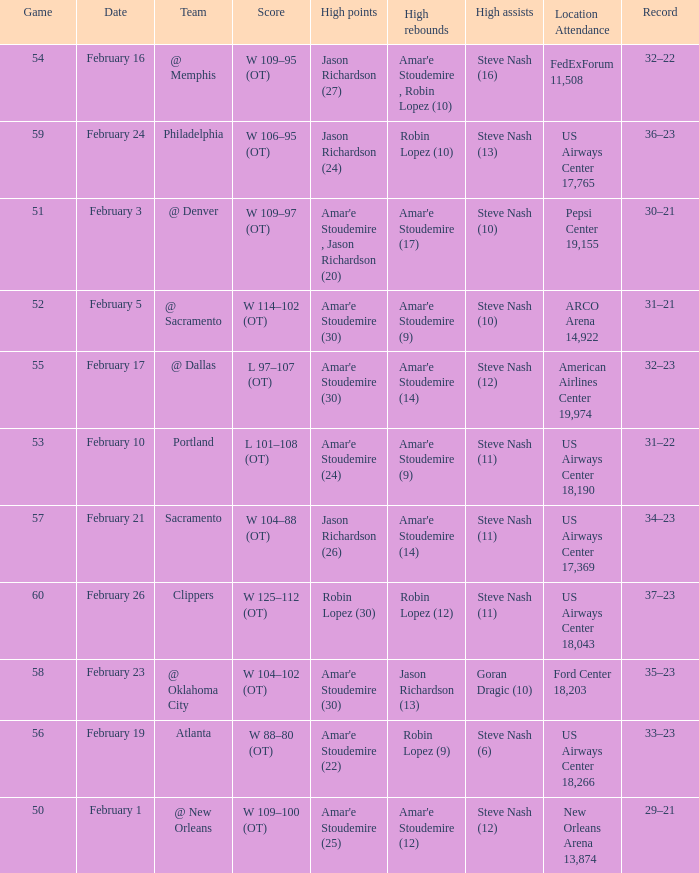Name the high points for pepsi center 19,155 Amar'e Stoudemire , Jason Richardson (20). 